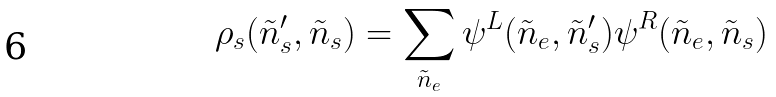<formula> <loc_0><loc_0><loc_500><loc_500>\rho _ { s } ( \tilde { n } _ { s } ^ { \prime } , \tilde { n } _ { s } ) = \sum _ { \tilde { n } _ { e } } \psi ^ { L } ( \tilde { n } _ { e } , \tilde { n } _ { s } ^ { \prime } ) \psi ^ { R } ( \tilde { n } _ { e } , \tilde { n } _ { s } )</formula> 